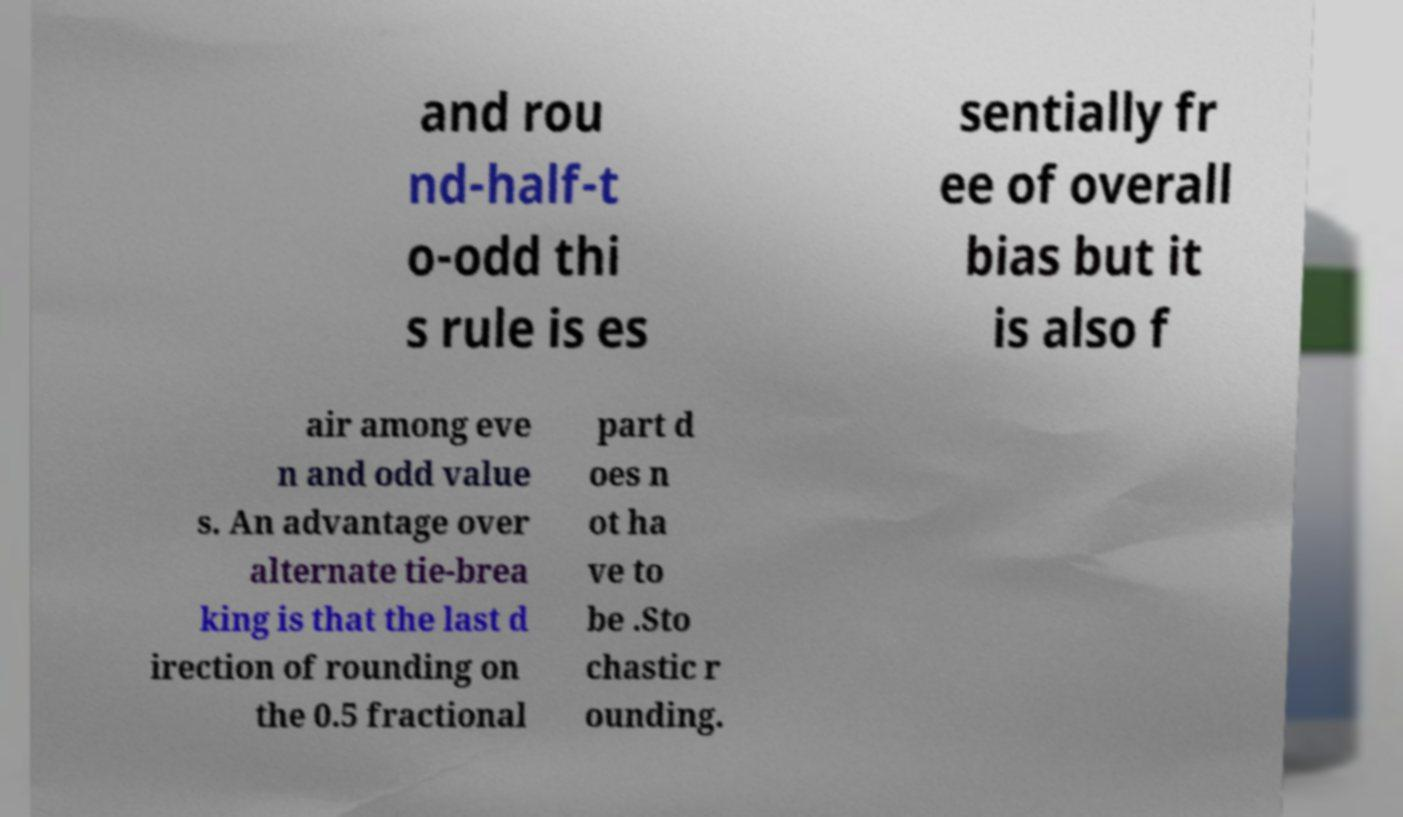I need the written content from this picture converted into text. Can you do that? and rou nd-half-t o-odd thi s rule is es sentially fr ee of overall bias but it is also f air among eve n and odd value s. An advantage over alternate tie-brea king is that the last d irection of rounding on the 0.5 fractional part d oes n ot ha ve to be .Sto chastic r ounding. 